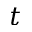Convert formula to latex. <formula><loc_0><loc_0><loc_500><loc_500>t</formula> 